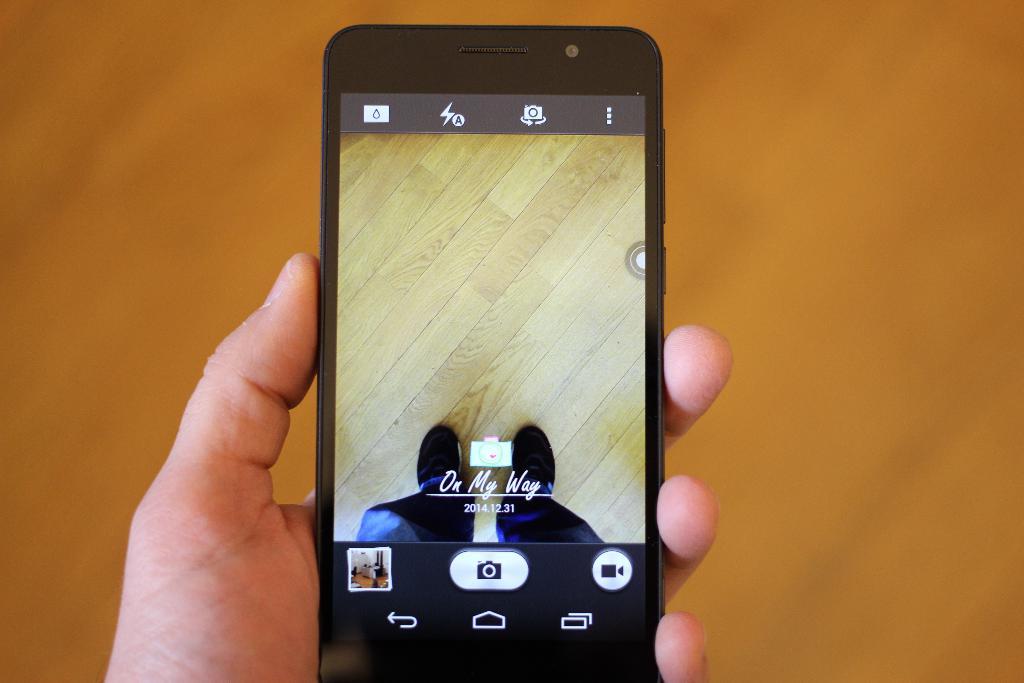What does the phone say on its screen?
Your response must be concise. On my way. What date is on the phone?
Keep it short and to the point. 2014.12.31. 